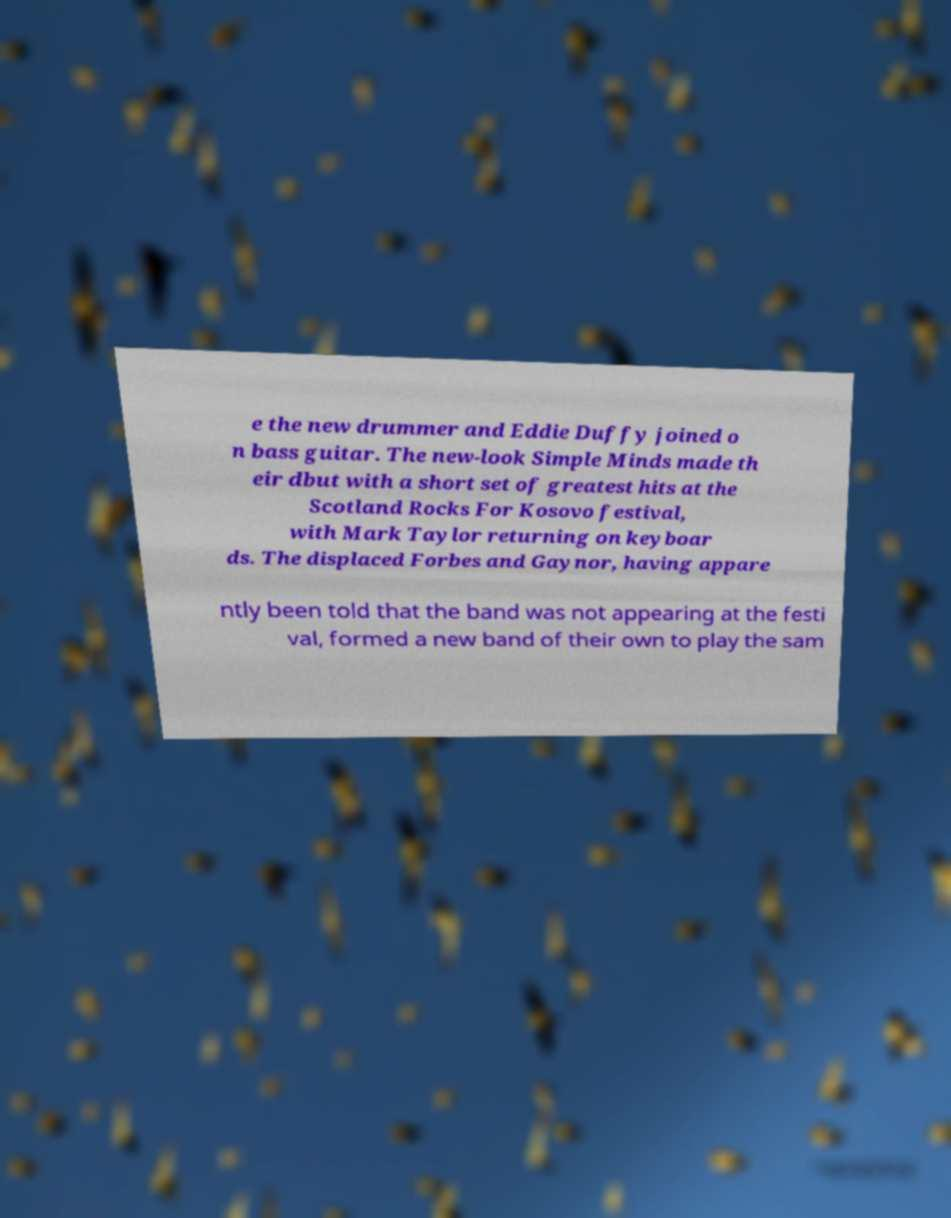I need the written content from this picture converted into text. Can you do that? e the new drummer and Eddie Duffy joined o n bass guitar. The new-look Simple Minds made th eir dbut with a short set of greatest hits at the Scotland Rocks For Kosovo festival, with Mark Taylor returning on keyboar ds. The displaced Forbes and Gaynor, having appare ntly been told that the band was not appearing at the festi val, formed a new band of their own to play the sam 